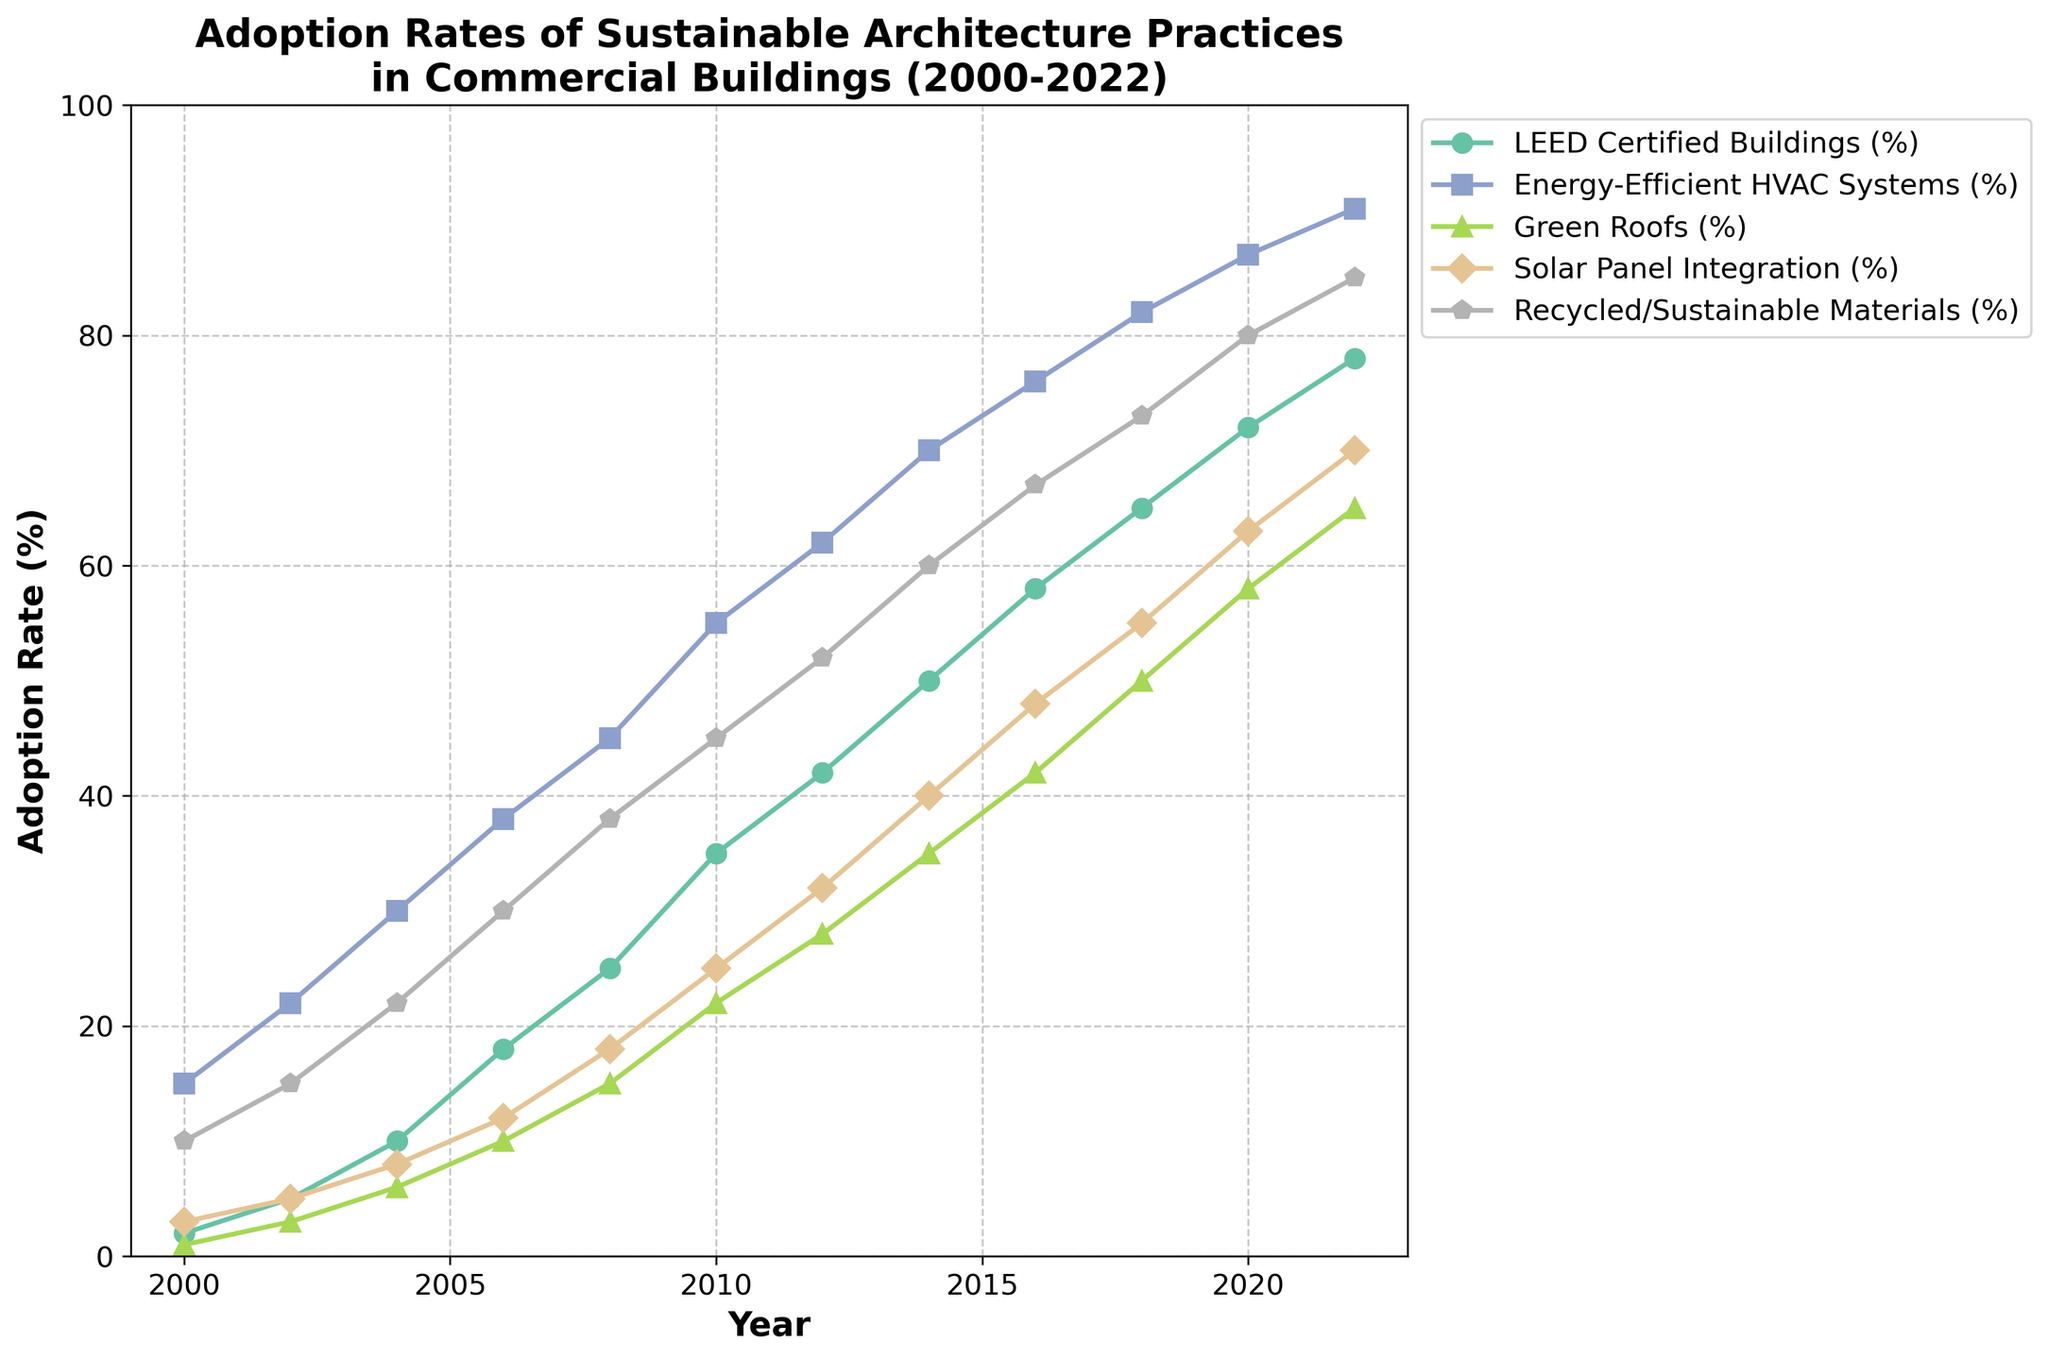What is the adoption rate of LEED Certified Buildings in 2018? Check the plot line corresponding to LEED Certified Buildings and find the value for the year 2018.
Answer: 65% How much did the adoption rate of Green Roofs increase from 2006 to 2016? Look at the value for Green Roofs in 2006, which is 10%, and in 2016, which is 42%. Calculate the difference: 42% - 10% = 32%.
Answer: 32% Which sustainable practice had the highest adoption rate in 2010? Compare the values for all sustainable practices in 2010. Energy-Efficient HVAC Systems had the highest adoption rate at 55%.
Answer: Energy-Efficient HVAC Systems In which year did Solar Panel Integration reach a 55% adoption rate? Find the year on the plot where the Solar Panel Integration line crosses the 55% mark. This occurs in 2018.
Answer: 2018 What is the difference in adoption rates between Energy-Efficient HVAC Systems and Recycled/Sustainable Materials in 2022? Look at the 2022 values for both Energy-Efficient HVAC Systems (91%) and Recycled/Sustainable Materials (85%), then calculate the difference: 91% - 85% = 6%.
Answer: 6% What is the average adoption rate of LEED Certified Buildings over the years 2000, 2006, and 2012? Identify the values for LEED Certified Buildings in 2000 (2%), 2006 (18%), and 2012 (42%). Calculate the average: (2% + 18% + 42%) / 3 = 62% / 3 ≈ 20.67%.
Answer: 20.67% Which sustainable practice showed the most consistent growth trend from 2000 to 2022? Analyze the plot lines for all sustainable practices. Recycled/Sustainable Materials shows a steady and consistent upward trend across the years from 2000 (10%) to 2022 (85%).
Answer: Recycled/Sustainable Materials How did the adoption rate of Green Roofs in 2020 compare to its adoption rate in 2008? Check the values of Green Roofs in 2020 (58%) and 2008 (15%) and compare them.
Answer: Increased by 43 percentage points What is the combined adoption rate of Energy-Efficient HVAC Systems and Solar Panel Integration in 2018? Identify the 2018 adoption rates for Energy-Efficient HVAC Systems (82%) and Solar Panel Integration (55%). Sum them up: 82% + 55% = 137%.
Answer: 137% In which year did the adoption rate of Recycled/Sustainable Materials exceed 50%? Find the first year on the plot where the Recycled/Sustainable Materials line surpasses the 50% adoption rate. This occurs in 2012.
Answer: 2012 